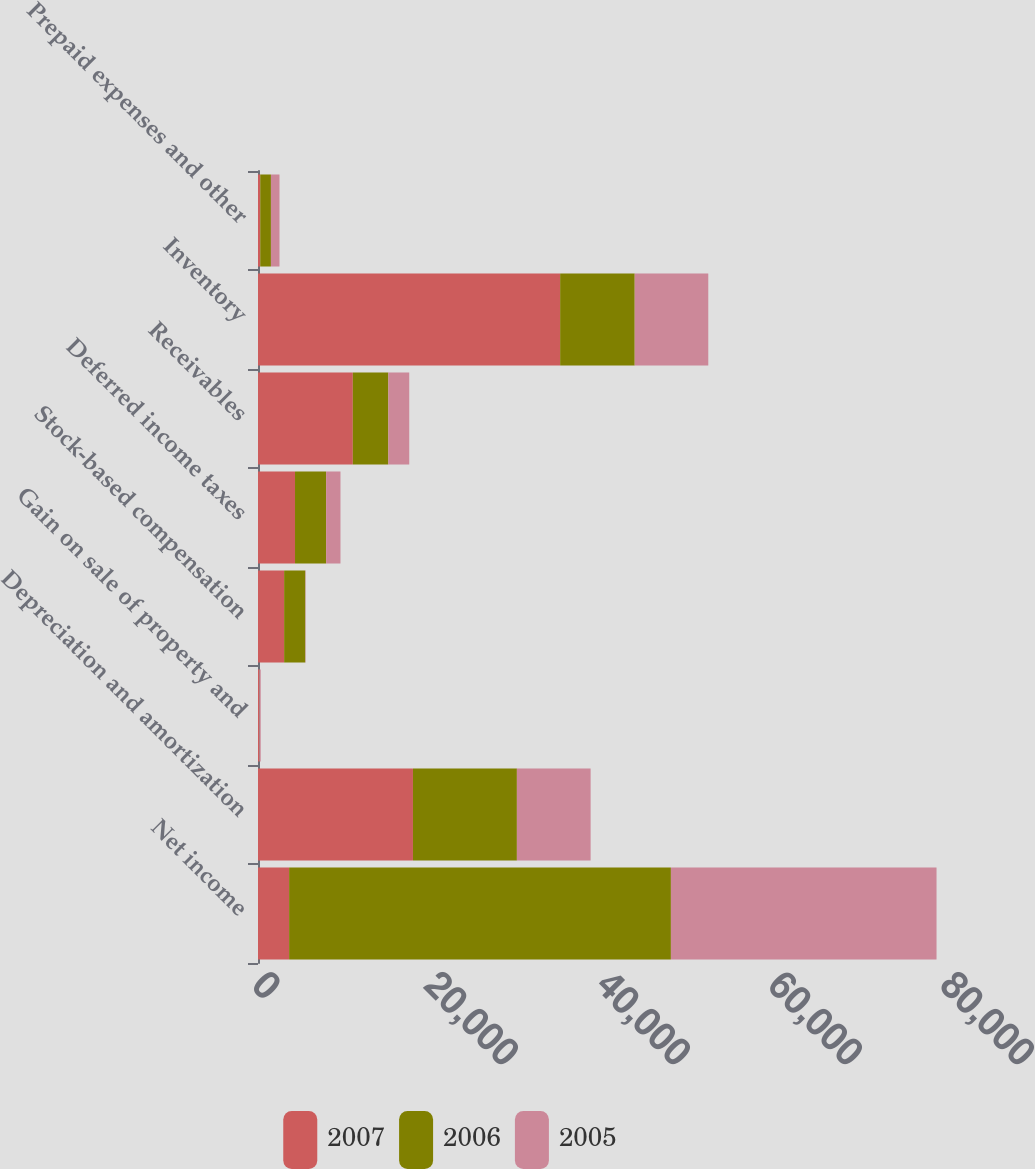Convert chart. <chart><loc_0><loc_0><loc_500><loc_500><stacked_bar_chart><ecel><fcel>Net income<fcel>Depreciation and amortization<fcel>Gain on sale of property and<fcel>Stock-based compensation<fcel>Deferred income taxes<fcel>Receivables<fcel>Inventory<fcel>Prepaid expenses and other<nl><fcel>2007<fcel>3618<fcel>18018<fcel>138<fcel>3039<fcel>4304<fcel>11026<fcel>35134<fcel>261<nl><fcel>2006<fcel>44395<fcel>12086<fcel>20<fcel>2461<fcel>3618<fcel>4133<fcel>8671<fcel>1242<nl><fcel>2005<fcel>30887<fcel>8574<fcel>159<fcel>42<fcel>1667<fcel>2429<fcel>8554<fcel>996<nl></chart> 